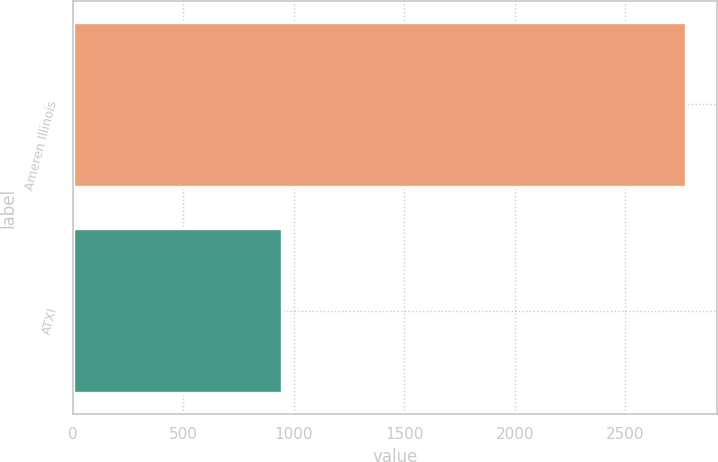Convert chart to OTSL. <chart><loc_0><loc_0><loc_500><loc_500><bar_chart><fcel>Ameren Illinois<fcel>ATXI<nl><fcel>2775<fcel>945<nl></chart> 